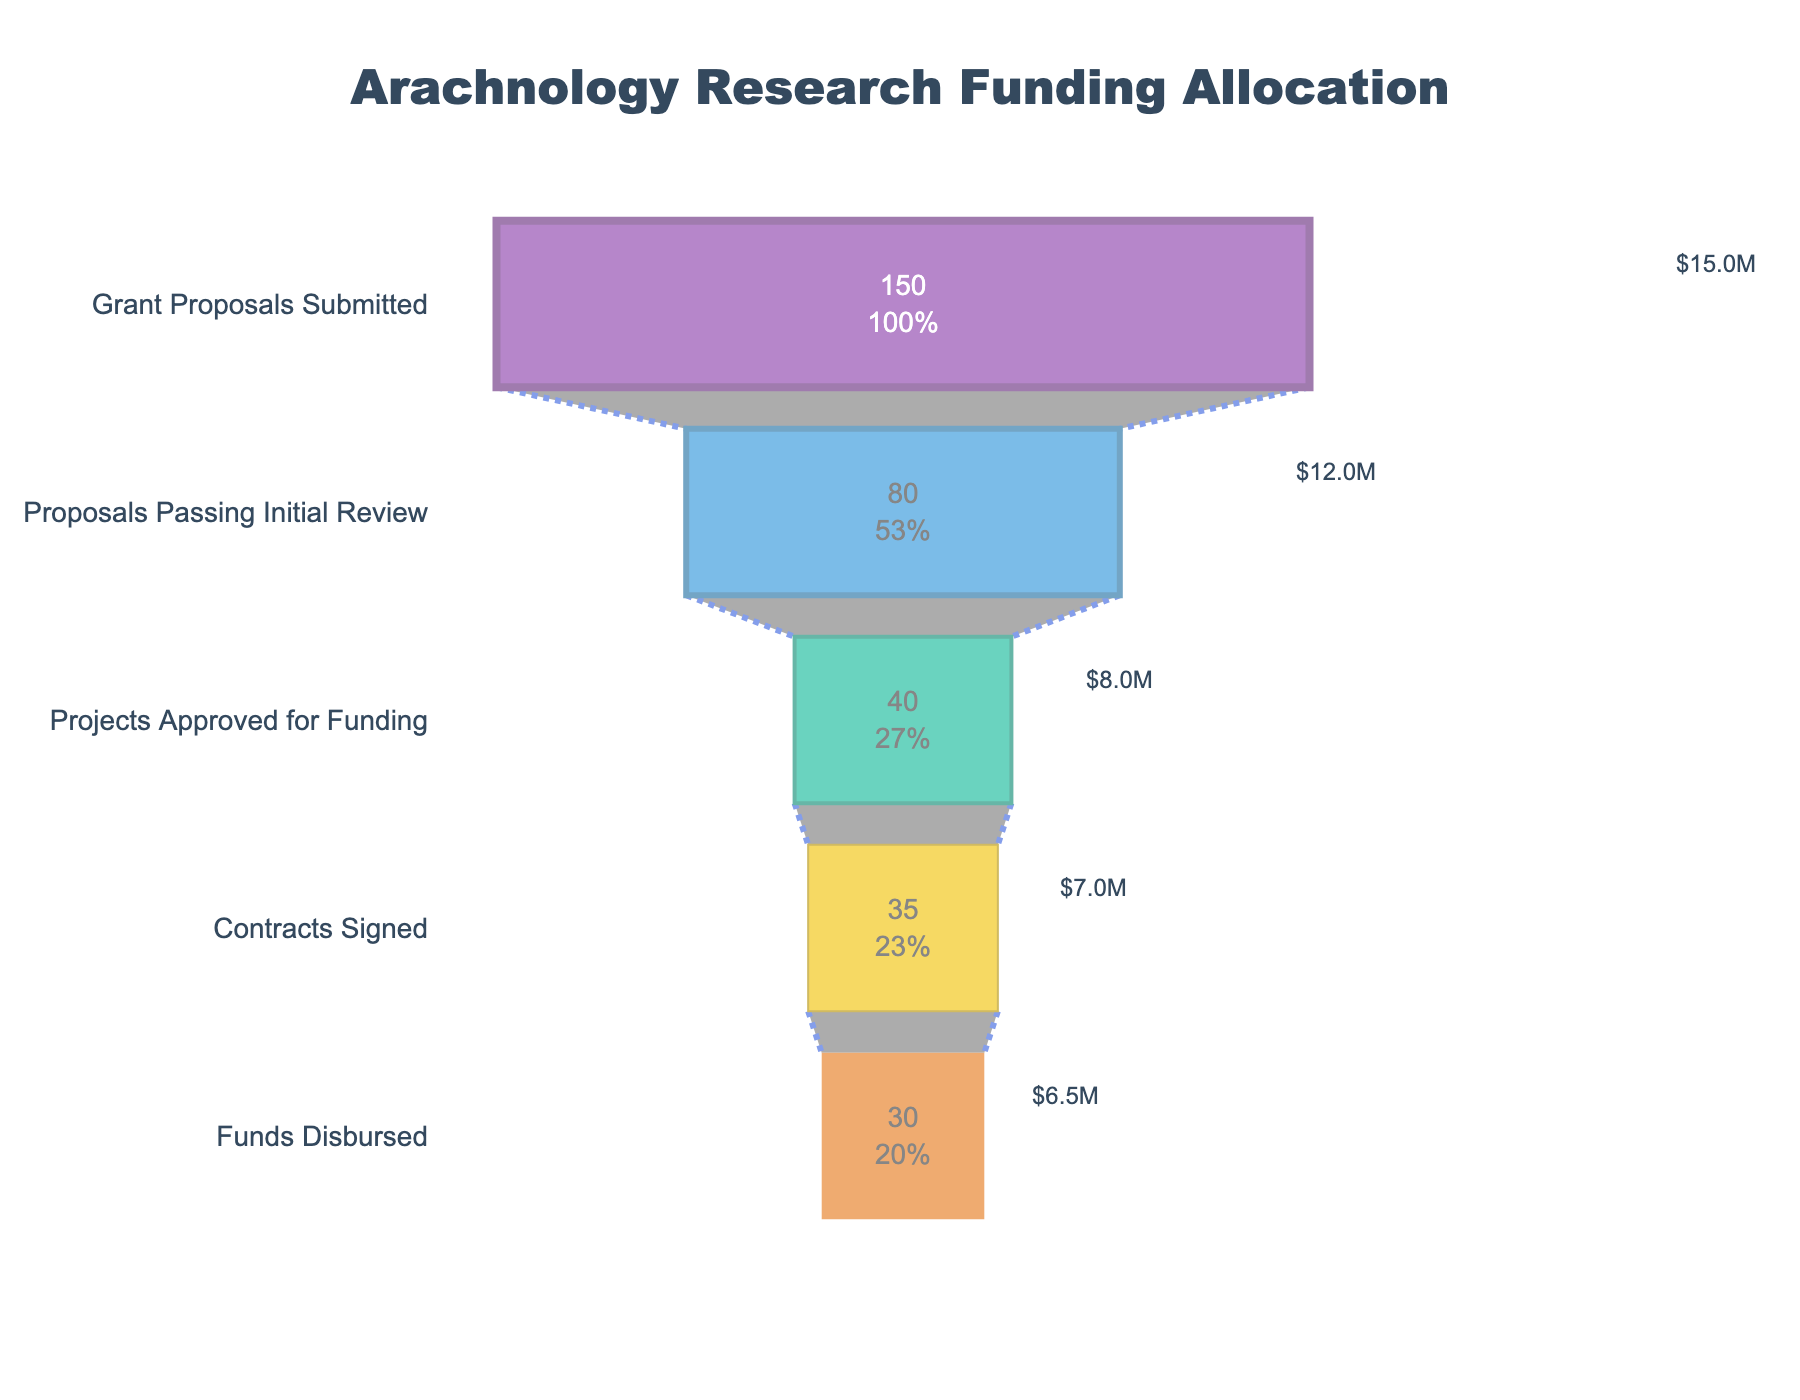what is the title of the funnel chart? The title of the funnel chart is placed at the top of the figure and is displayed in bold large font for easy visibility.
Answer: Arachnology Research Funding Allocation How many projects were approved for funding? Look at the stage labeled "Projects Approved for Funding" and check the number of projects reported.
Answer: 40 Compare the number of projects that passed the initial review to the number of projects where contracts were signed. Which stage has more projects? Check the data for the "Proposals Passing Initial Review" stage and the "Contracts Signed" stage, and compare the numbers given for each.
Answer: Proposals Passing Initial Review What percentage of submitted grant proposals were approved for funding? Divide the number of "Projects Approved for Funding" by the total "Grant Proposals Submitted" and multiply by 100 to get the percentage. (40 / 150) * 100 = 26.67
Answer: 26.67% How much total funding was disbursed? Look at the "Funds Disbursed" stage and check the funding amount reported for this stage.
Answer: $6500000 Which stage sees the largest drop in the number of projects compared to the previous stage? Calculate the difference in the number of projects between each consecutive stage and identify the stage with the largest drop. Compare (150 - 80), (80 - 40), (40 - 35), (35 - 30).
Answer: Between "Grant Proposals Submitted" and "Proposals Passing Initial Review" By how much did the funding amount decrease from the "Proposals Passing Initial Review" stage to the "Contracts Signed" stage? Subtract the funding amount in the "Contracts Signed" stage from that in the "Proposals Passing Initial Review" stage to find the decrease. 12,000,000 - 7,000,000 = 5,000,000
Answer: $5,000,000 What color is used to represent the 'Contracts Signed' stage in the funnel chart? Identify the color associated with the "Contracts Signed" stage from the visual representation.
Answer: Yellow/gold What is the average funding amount per project for the funded projects? Divide the total funding amount disbursed by the number of funded projects (30). 6,500,000 / 30 = 216,666.67
Answer: $216,666.67 Which stage remains with the highest funding amount? Check the funding amount at each stage and find the maximum value presented.
Answer: Grant Proposals Submitted ($15,000,000) 